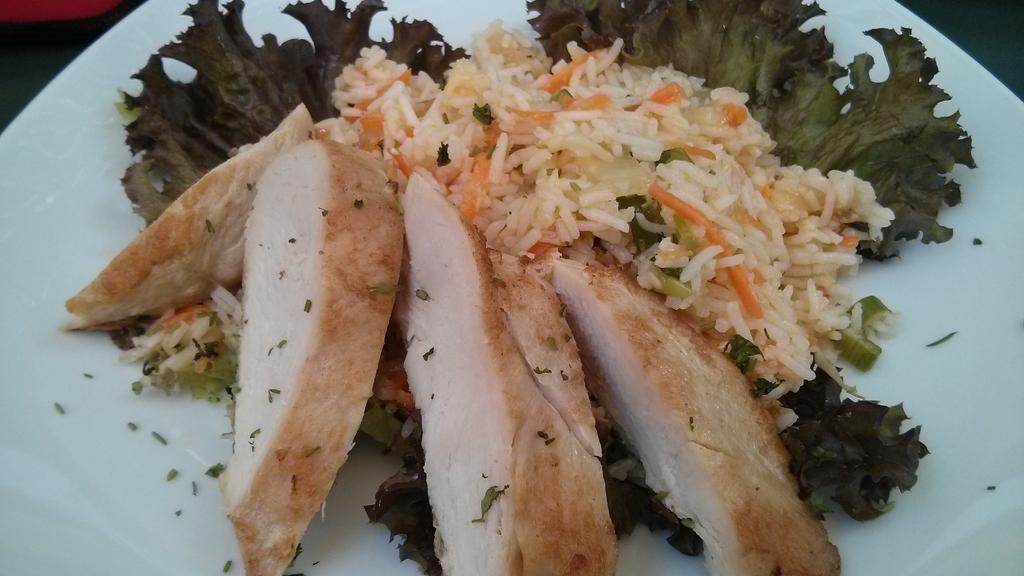How would you summarize this image in a sentence or two? In this image there are food items in a plate. Beside the plate there is some object. 